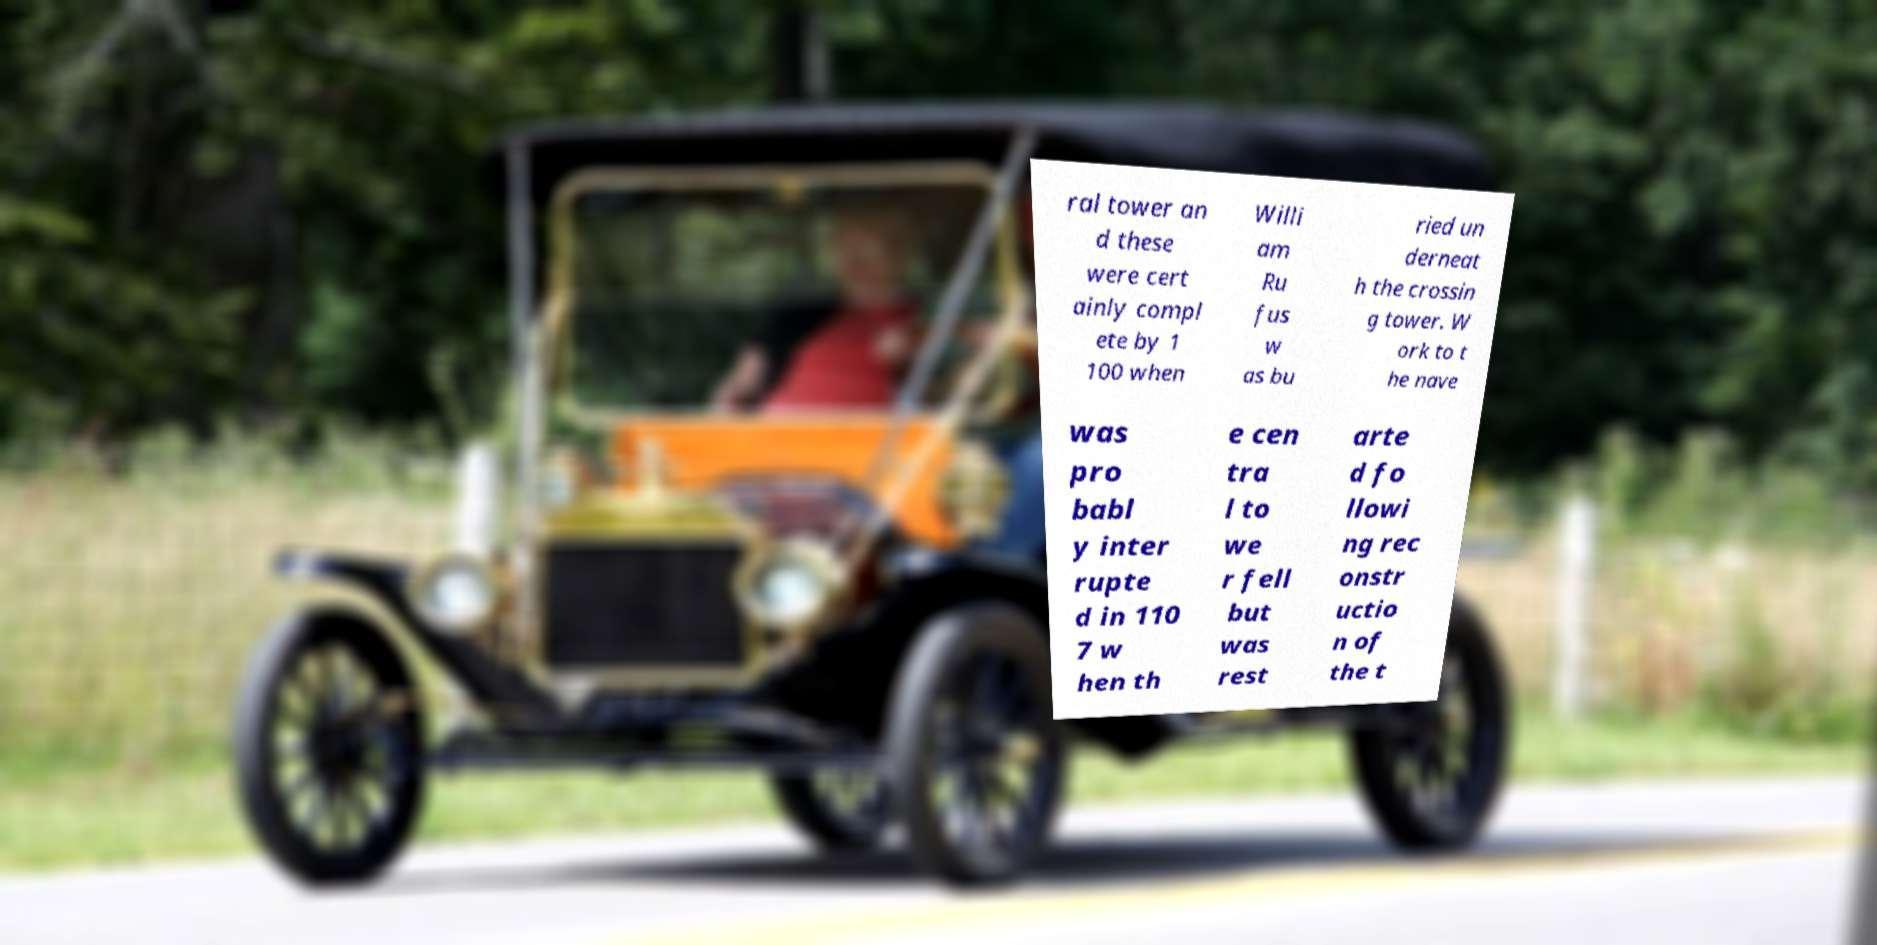Could you extract and type out the text from this image? ral tower an d these were cert ainly compl ete by 1 100 when Willi am Ru fus w as bu ried un derneat h the crossin g tower. W ork to t he nave was pro babl y inter rupte d in 110 7 w hen th e cen tra l to we r fell but was rest arte d fo llowi ng rec onstr uctio n of the t 